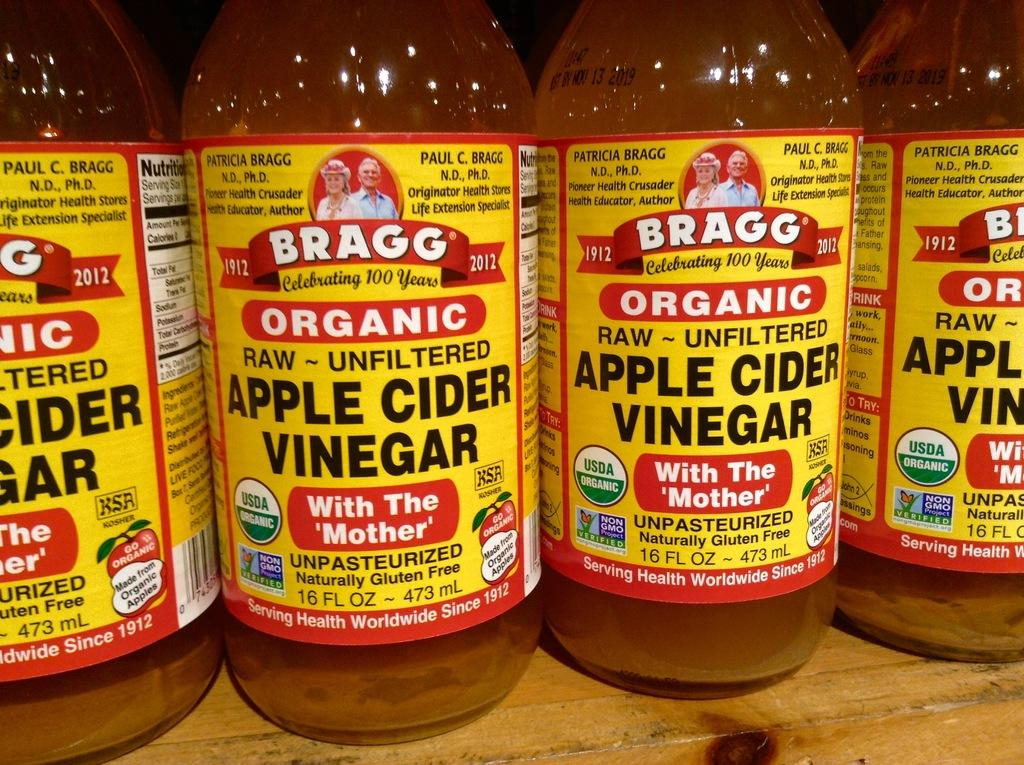How many bottles are visible in the image? There are four bottles in the image. What is the surface on which the bottles are placed? The bottles are on a wooden surface. Are there any distinguishing features on the bottles? Yes, there is a label on the bottles. What type of dress is being worn by the bottle in the image? Bottles do not wear dresses; they are inanimate objects. 